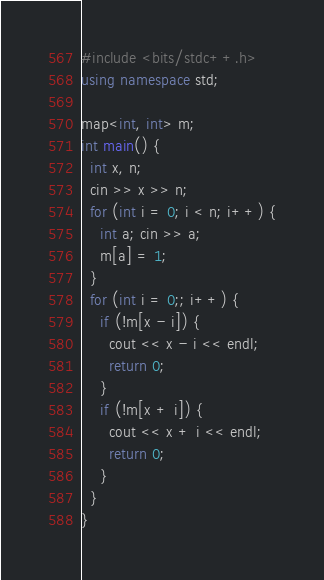<code> <loc_0><loc_0><loc_500><loc_500><_C++_>#include <bits/stdc++.h>
using namespace std;

map<int, int> m;
int main() {
  int x, n;
  cin >> x >> n;
  for (int i = 0; i < n; i++) {
   	int a; cin >> a;
   	m[a] = 1;
  }
  for (int i = 0;; i++) {
    if (!m[x - i]) {
      cout << x - i << endl;
      return 0;
    }
    if (!m[x + i]) {
      cout << x + i << endl;
      return 0;
    }
  }
}</code> 